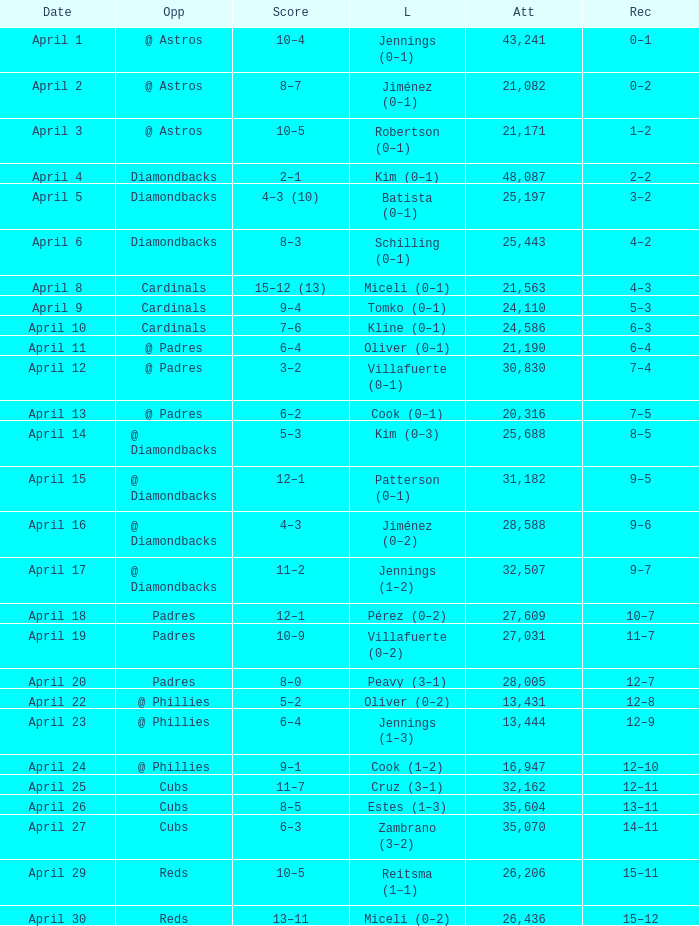What is the team's record on april 23? 12–9. 